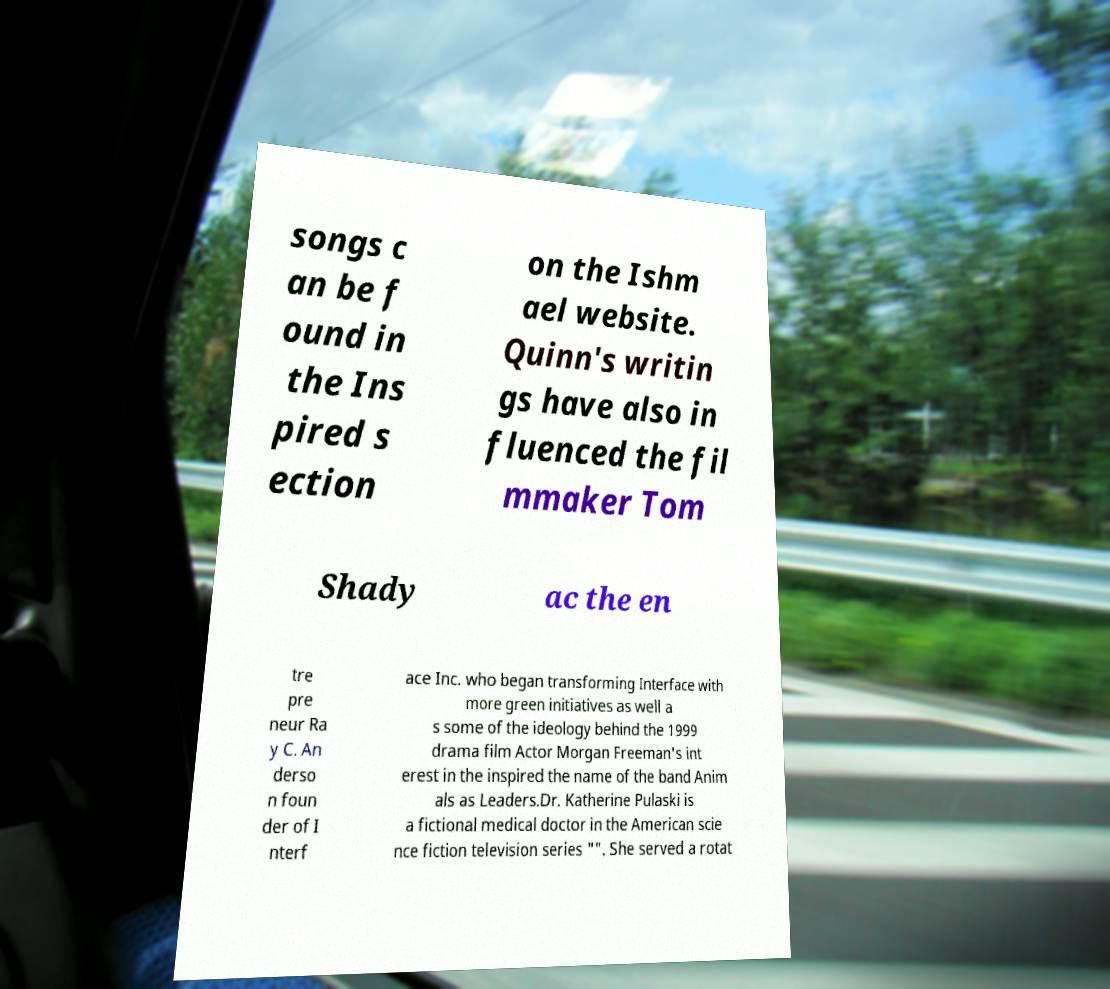Please identify and transcribe the text found in this image. songs c an be f ound in the Ins pired s ection on the Ishm ael website. Quinn's writin gs have also in fluenced the fil mmaker Tom Shady ac the en tre pre neur Ra y C. An derso n foun der of I nterf ace Inc. who began transforming Interface with more green initiatives as well a s some of the ideology behind the 1999 drama film Actor Morgan Freeman's int erest in the inspired the name of the band Anim als as Leaders.Dr. Katherine Pulaski is a fictional medical doctor in the American scie nce fiction television series "". She served a rotat 